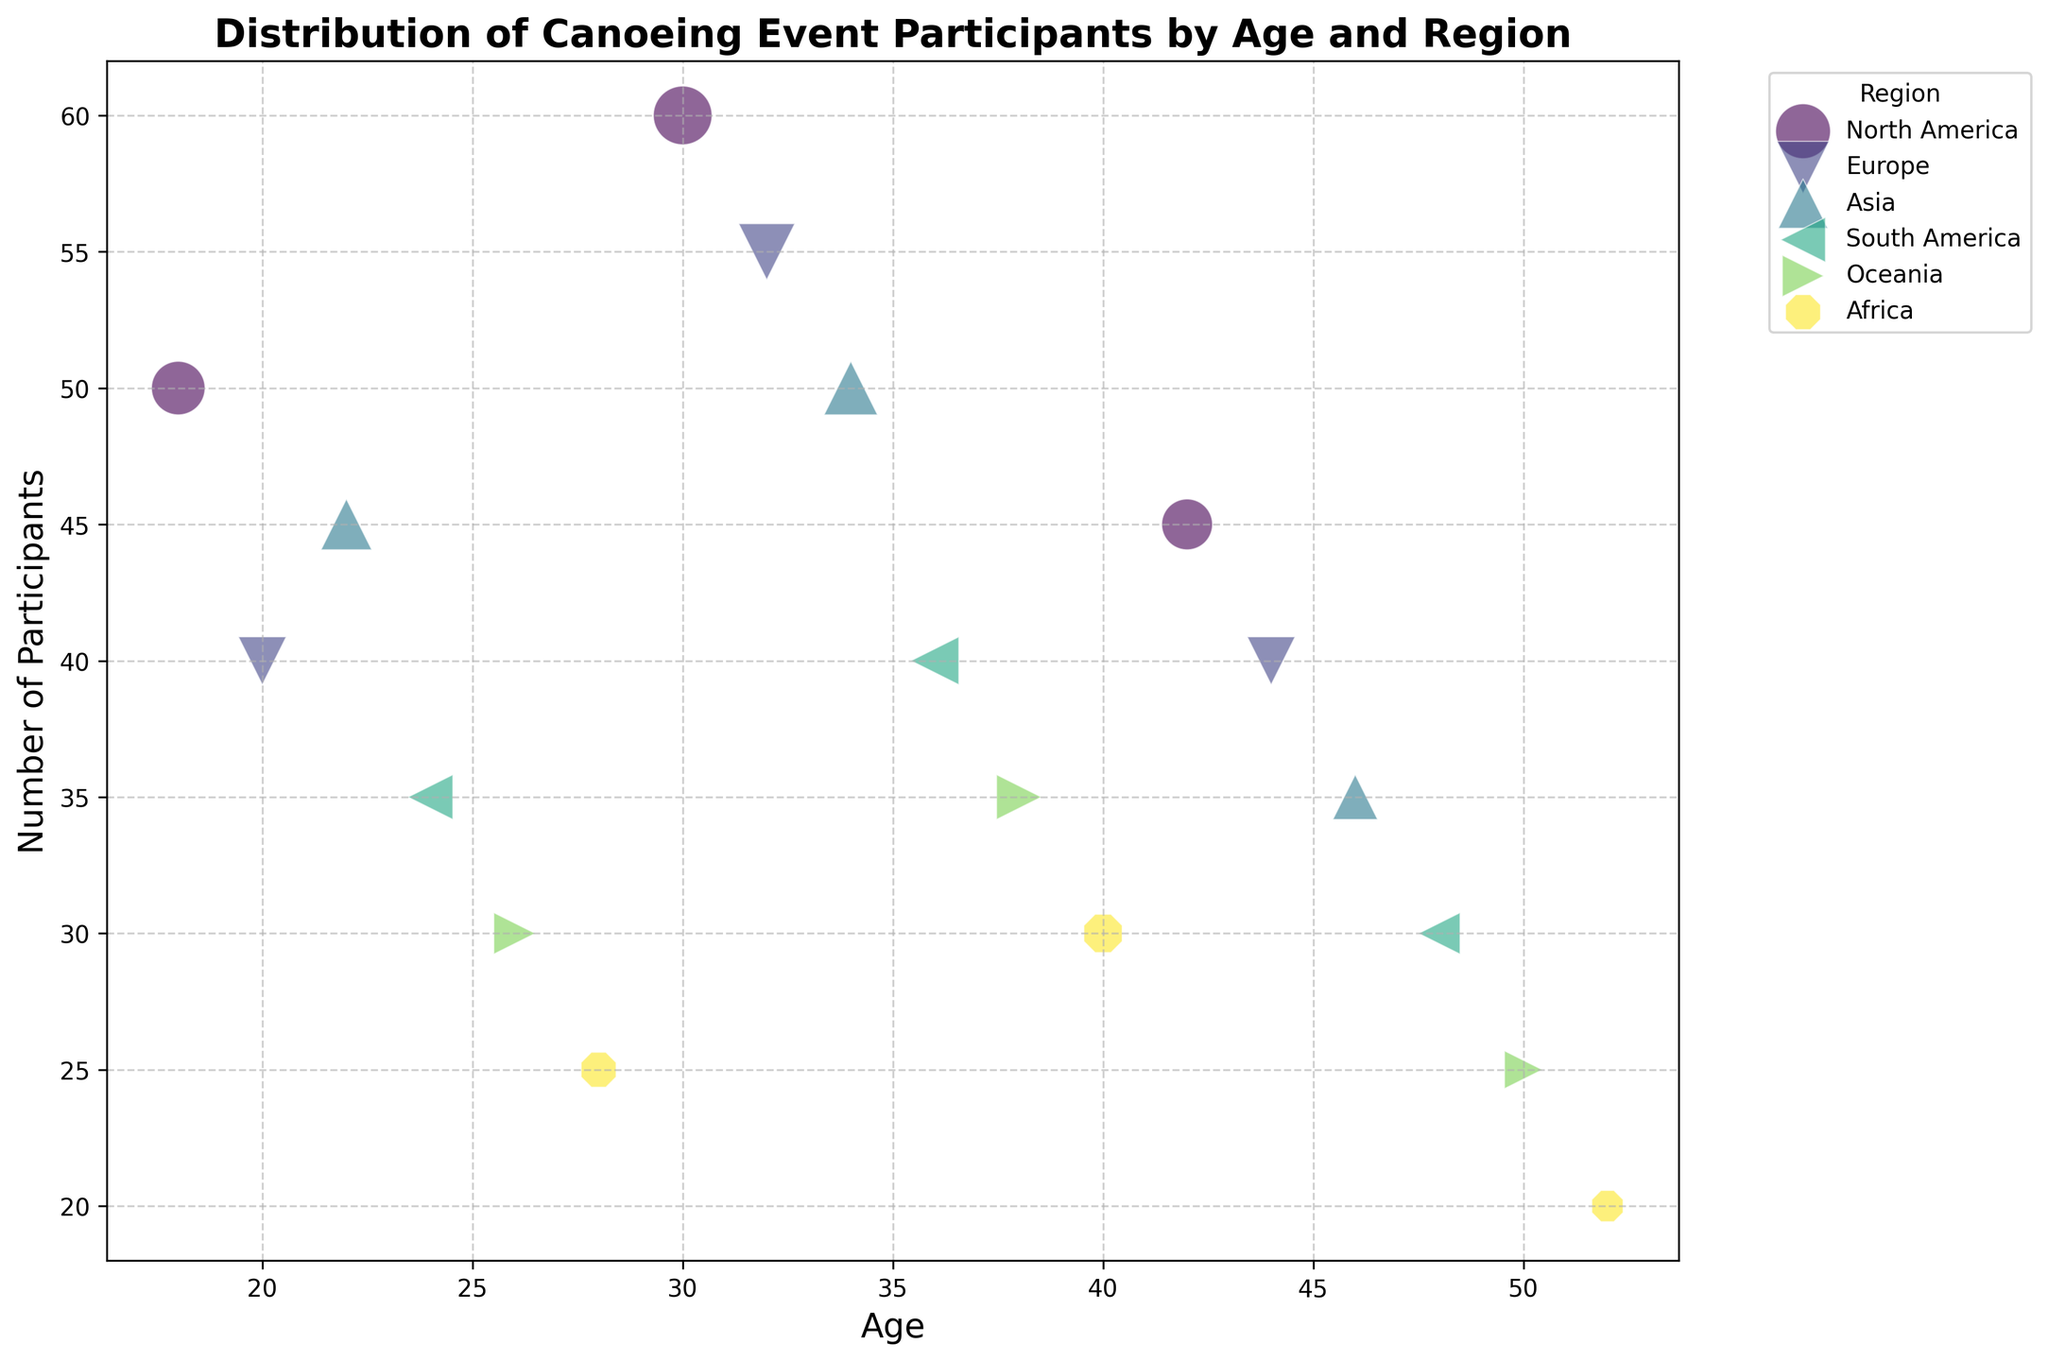What is the average number of participants from North America? Identify the ages for North America: 18, 30, and 42. Summing their participants gives 50 + 60 + 45 = 155. Since there are 3 age groups, the average is 155 / 3 = 51.67
Answer: 51.67 Which region has the highest number of participants? By examining the bubble sizes, North America at age 30 has the largest bubble, indicating the highest number of 60 participants.
Answer: North America How many participants are there in total from South America? Find all age groups and participants for South America: 24, 36, and 48. Add the participants: 35 + 40 + 30 = 105.
Answer: 105 Compare the number of participants from Asia at age 22 and age 46. Which age group has more participants and by how many? Participants at age 22 = 45 and at age 46 = 35. Subtracting the two: 45 - 35 = 10. Age 22 has 10 more participants.
Answer: Age 22, 10 more Which age group in Europe has the least participants and how many? For Europe, the ages and participants are: 20 (40), 32 (55), and 44 (40). The least number is 40.
Answer: Age 20 and 44, 40 participants At what age do Oceania participants reach the highest count? Examine Oceania's bubbles (ages 26, 38, 50): the largest bubble is at age 38 with 35 participants.
Answer: Age 38 Is the number of participants from Africa at age 28 greater than age 40? If yes, by how much? Participants at age 28 = 25, age 40 = 30. Here, age 40 is greater, thus the difference is 30 - 25 = 5.
Answer: No, age 40 is greater by 5 Across all ages, which region has the most consistent number of participants (lowest variation)? By visual inspection, regions like Africa have evenly-sized bubbles, whereas others fluctuate more.
Answer: Africa (least variation apparent) Which age group has the least number of participants across all regions? Look for the smallest bubble across the graph: age 52 has the smallest bubble with 20 participants (Africa).
Answer: Age 52 Between ages 30 and 34, how many total participants are there combining all regions? Sum participants for ages 30 (60), 32 (55), and 34 (50): 60 + 55 + 50 = 165.
Answer: 165 